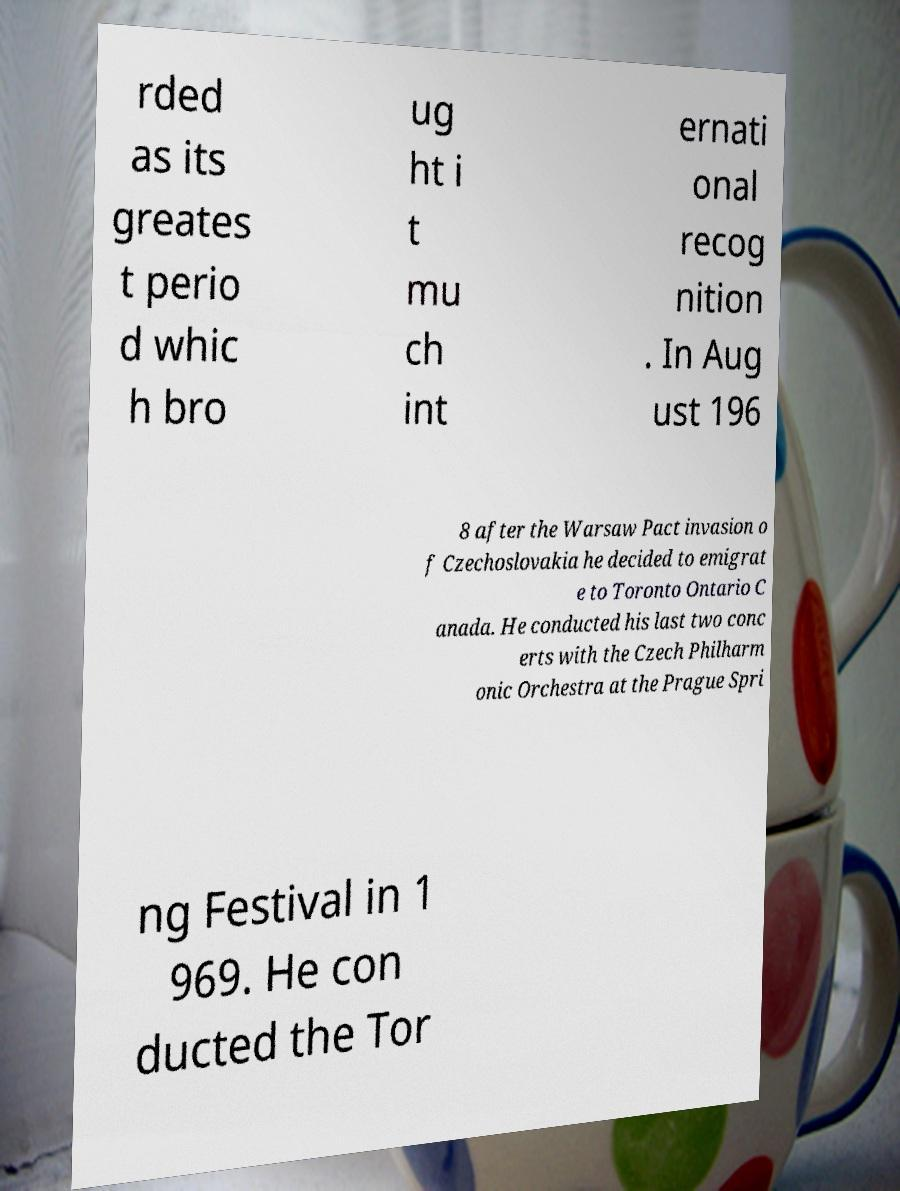Can you accurately transcribe the text from the provided image for me? rded as its greates t perio d whic h bro ug ht i t mu ch int ernati onal recog nition . In Aug ust 196 8 after the Warsaw Pact invasion o f Czechoslovakia he decided to emigrat e to Toronto Ontario C anada. He conducted his last two conc erts with the Czech Philharm onic Orchestra at the Prague Spri ng Festival in 1 969. He con ducted the Tor 